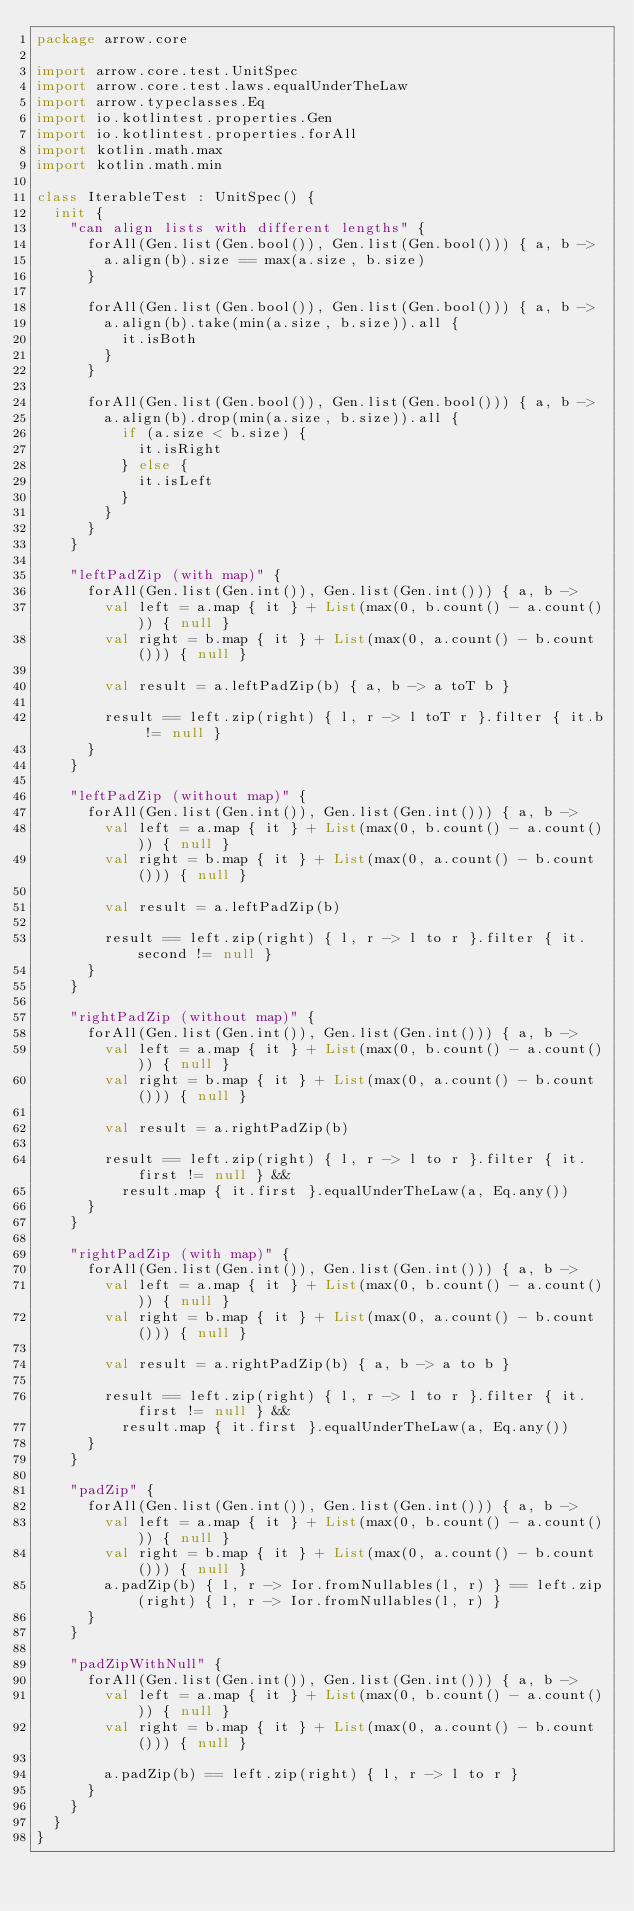Convert code to text. <code><loc_0><loc_0><loc_500><loc_500><_Kotlin_>package arrow.core

import arrow.core.test.UnitSpec
import arrow.core.test.laws.equalUnderTheLaw
import arrow.typeclasses.Eq
import io.kotlintest.properties.Gen
import io.kotlintest.properties.forAll
import kotlin.math.max
import kotlin.math.min

class IterableTest : UnitSpec() {
  init {
    "can align lists with different lengths" {
      forAll(Gen.list(Gen.bool()), Gen.list(Gen.bool())) { a, b ->
        a.align(b).size == max(a.size, b.size)
      }

      forAll(Gen.list(Gen.bool()), Gen.list(Gen.bool())) { a, b ->
        a.align(b).take(min(a.size, b.size)).all {
          it.isBoth
        }
      }

      forAll(Gen.list(Gen.bool()), Gen.list(Gen.bool())) { a, b ->
        a.align(b).drop(min(a.size, b.size)).all {
          if (a.size < b.size) {
            it.isRight
          } else {
            it.isLeft
          }
        }
      }
    }

    "leftPadZip (with map)" {
      forAll(Gen.list(Gen.int()), Gen.list(Gen.int())) { a, b ->
        val left = a.map { it } + List(max(0, b.count() - a.count())) { null }
        val right = b.map { it } + List(max(0, a.count() - b.count())) { null }

        val result = a.leftPadZip(b) { a, b -> a toT b }

        result == left.zip(right) { l, r -> l toT r }.filter { it.b != null }
      }
    }

    "leftPadZip (without map)" {
      forAll(Gen.list(Gen.int()), Gen.list(Gen.int())) { a, b ->
        val left = a.map { it } + List(max(0, b.count() - a.count())) { null }
        val right = b.map { it } + List(max(0, a.count() - b.count())) { null }

        val result = a.leftPadZip(b)

        result == left.zip(right) { l, r -> l to r }.filter { it.second != null }
      }
    }

    "rightPadZip (without map)" {
      forAll(Gen.list(Gen.int()), Gen.list(Gen.int())) { a, b ->
        val left = a.map { it } + List(max(0, b.count() - a.count())) { null }
        val right = b.map { it } + List(max(0, a.count() - b.count())) { null }

        val result = a.rightPadZip(b)

        result == left.zip(right) { l, r -> l to r }.filter { it.first != null } &&
          result.map { it.first }.equalUnderTheLaw(a, Eq.any())
      }
    }

    "rightPadZip (with map)" {
      forAll(Gen.list(Gen.int()), Gen.list(Gen.int())) { a, b ->
        val left = a.map { it } + List(max(0, b.count() - a.count())) { null }
        val right = b.map { it } + List(max(0, a.count() - b.count())) { null }

        val result = a.rightPadZip(b) { a, b -> a to b }

        result == left.zip(right) { l, r -> l to r }.filter { it.first != null } &&
          result.map { it.first }.equalUnderTheLaw(a, Eq.any())
      }
    }

    "padZip" {
      forAll(Gen.list(Gen.int()), Gen.list(Gen.int())) { a, b ->
        val left = a.map { it } + List(max(0, b.count() - a.count())) { null }
        val right = b.map { it } + List(max(0, a.count() - b.count())) { null }
        a.padZip(b) { l, r -> Ior.fromNullables(l, r) } == left.zip(right) { l, r -> Ior.fromNullables(l, r) }
      }
    }

    "padZipWithNull" {
      forAll(Gen.list(Gen.int()), Gen.list(Gen.int())) { a, b ->
        val left = a.map { it } + List(max(0, b.count() - a.count())) { null }
        val right = b.map { it } + List(max(0, a.count() - b.count())) { null }

        a.padZip(b) == left.zip(right) { l, r -> l to r }
      }
    }
  }
}
</code> 